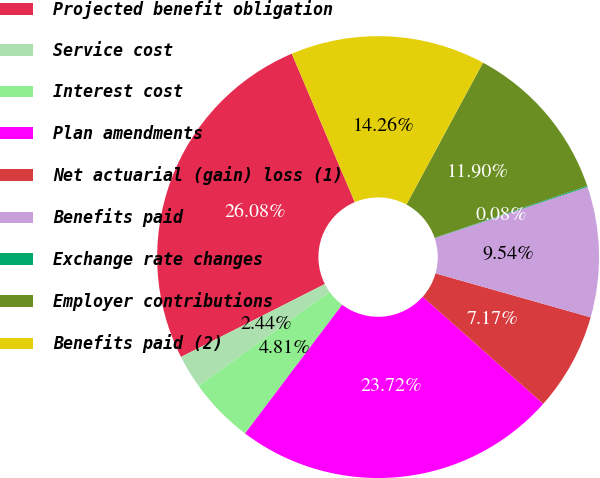<chart> <loc_0><loc_0><loc_500><loc_500><pie_chart><fcel>Projected benefit obligation<fcel>Service cost<fcel>Interest cost<fcel>Plan amendments<fcel>Net actuarial (gain) loss (1)<fcel>Benefits paid<fcel>Exchange rate changes<fcel>Employer contributions<fcel>Benefits paid (2)<nl><fcel>26.08%<fcel>2.44%<fcel>4.81%<fcel>23.72%<fcel>7.17%<fcel>9.54%<fcel>0.08%<fcel>11.9%<fcel>14.26%<nl></chart> 